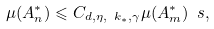Convert formula to latex. <formula><loc_0><loc_0><loc_500><loc_500>\mu ( A _ { n } ^ { \ast } ) \leqslant C _ { d , \eta , \ k _ { \ast } , \gamma } \mu ( A _ { m } ^ { \ast } ) ^ { \ } s ,</formula> 